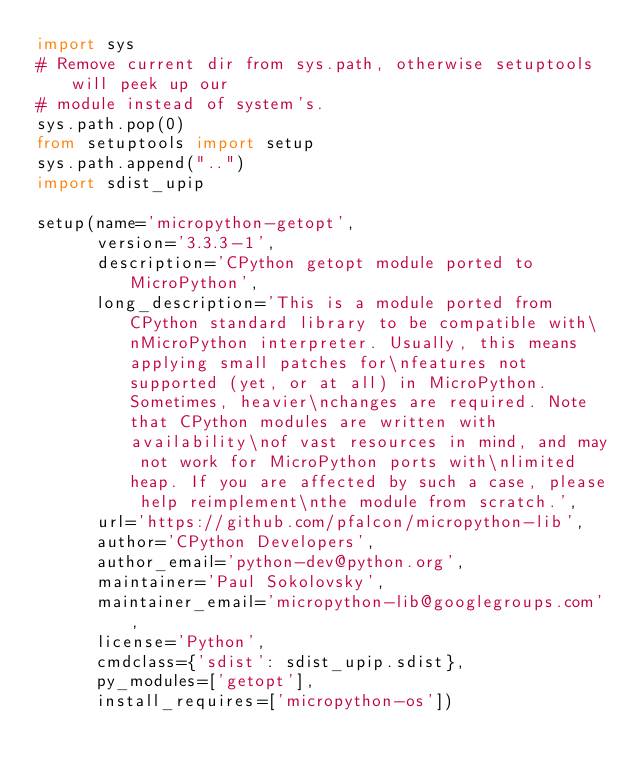Convert code to text. <code><loc_0><loc_0><loc_500><loc_500><_Python_>import sys
# Remove current dir from sys.path, otherwise setuptools will peek up our
# module instead of system's.
sys.path.pop(0)
from setuptools import setup
sys.path.append("..")
import sdist_upip

setup(name='micropython-getopt',
      version='3.3.3-1',
      description='CPython getopt module ported to MicroPython',
      long_description='This is a module ported from CPython standard library to be compatible with\nMicroPython interpreter. Usually, this means applying small patches for\nfeatures not supported (yet, or at all) in MicroPython. Sometimes, heavier\nchanges are required. Note that CPython modules are written with availability\nof vast resources in mind, and may not work for MicroPython ports with\nlimited heap. If you are affected by such a case, please help reimplement\nthe module from scratch.',
      url='https://github.com/pfalcon/micropython-lib',
      author='CPython Developers',
      author_email='python-dev@python.org',
      maintainer='Paul Sokolovsky',
      maintainer_email='micropython-lib@googlegroups.com',
      license='Python',
      cmdclass={'sdist': sdist_upip.sdist},
      py_modules=['getopt'],
      install_requires=['micropython-os'])
</code> 